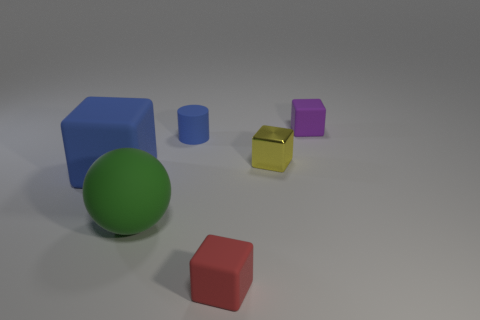The sphere that is the same material as the small cylinder is what color?
Your answer should be compact. Green. What number of large rubber blocks have the same color as the tiny rubber cylinder?
Your answer should be compact. 1. What number of objects are either tiny yellow matte things or tiny cubes?
Keep it short and to the point. 3. The purple rubber object that is the same size as the red matte block is what shape?
Ensure brevity in your answer.  Cube. What number of rubber blocks are both on the right side of the large blue block and behind the small red object?
Your response must be concise. 1. What material is the block that is behind the tiny blue matte thing?
Make the answer very short. Rubber. What is the size of the green sphere that is the same material as the small red object?
Ensure brevity in your answer.  Large. There is a green rubber ball right of the big matte block; does it have the same size as the rubber block that is behind the yellow metallic thing?
Keep it short and to the point. No. There is a red object that is the same size as the blue matte cylinder; what material is it?
Offer a very short reply. Rubber. There is a object that is to the left of the red rubber cube and behind the yellow shiny object; what material is it?
Provide a succinct answer. Rubber. 